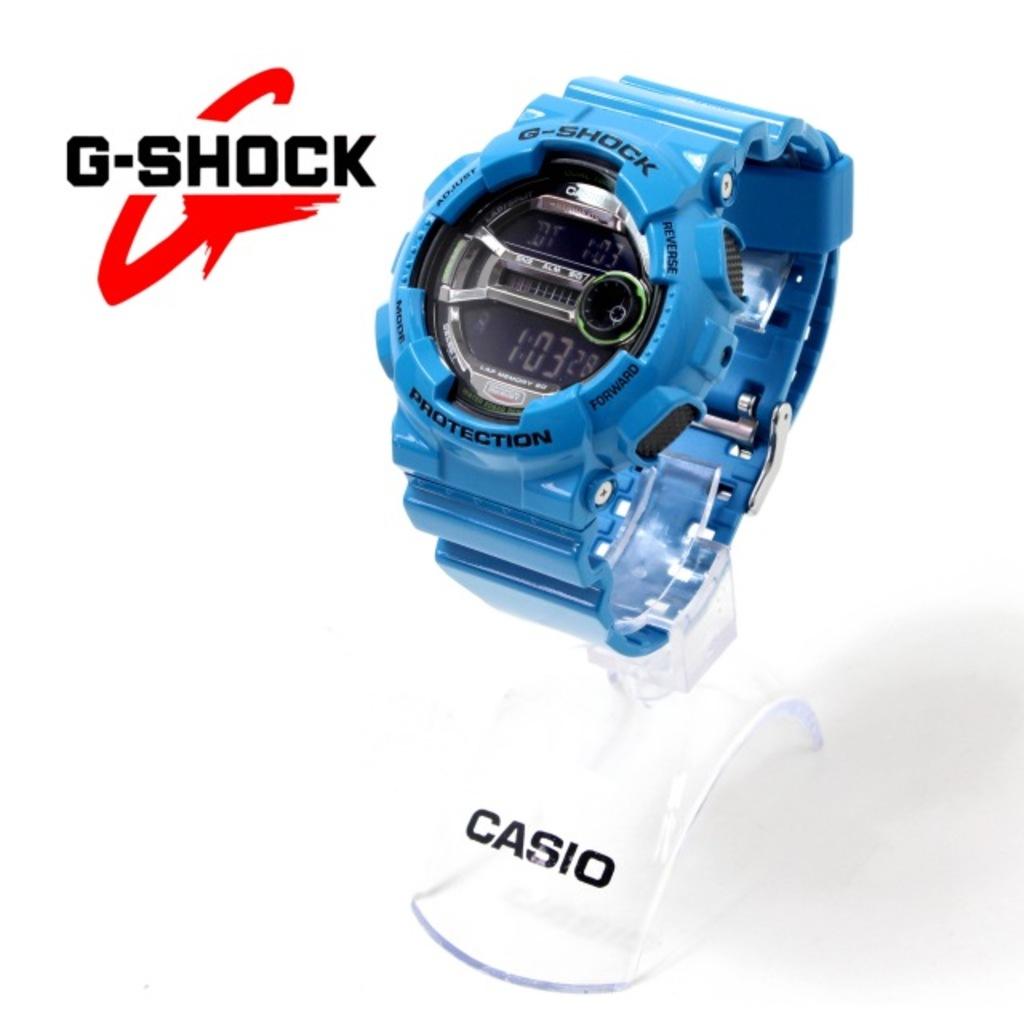What brand is this watch?
Provide a succinct answer. Casio. What does the watch say on the bottom of its face?
Provide a succinct answer. Protection. 